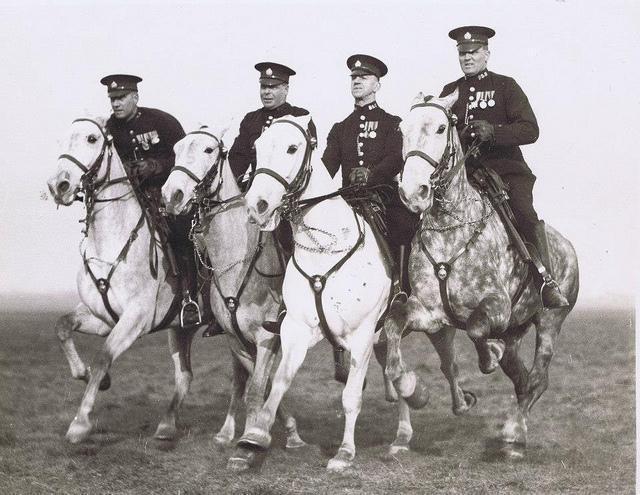How many men are in the pic?
Give a very brief answer. 4. How many people are there?
Give a very brief answer. 4. How many horses are there?
Give a very brief answer. 4. How many zebras are there?
Give a very brief answer. 0. 